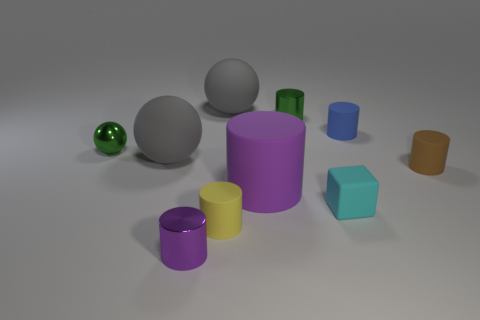How many tiny blue matte things are the same shape as the tiny brown rubber thing?
Offer a terse response. 1. What shape is the brown thing that is made of the same material as the yellow thing?
Your answer should be very brief. Cylinder. There is a large thing that is to the right of the big gray matte ball behind the small ball; what is its color?
Provide a succinct answer. Purple. Is the color of the big cylinder the same as the tiny sphere?
Give a very brief answer. No. What material is the purple cylinder that is in front of the purple cylinder that is to the right of the tiny yellow rubber thing?
Make the answer very short. Metal. There is a small blue thing that is the same shape as the big purple matte thing; what is its material?
Your answer should be compact. Rubber. Are there any tiny yellow rubber cylinders on the left side of the gray matte thing in front of the gray thing that is right of the tiny yellow cylinder?
Your answer should be compact. No. How many other things are the same color as the matte cube?
Provide a succinct answer. 0. How many objects are on the left side of the cyan rubber block and to the right of the blue rubber object?
Give a very brief answer. 0. The purple metallic object is what shape?
Give a very brief answer. Cylinder. 